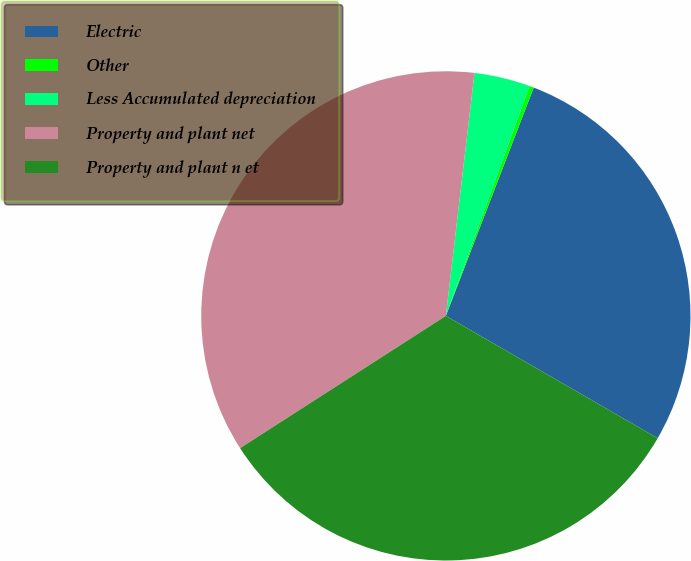Convert chart to OTSL. <chart><loc_0><loc_0><loc_500><loc_500><pie_chart><fcel>Electric<fcel>Other<fcel>Less Accumulated depreciation<fcel>Property and plant net<fcel>Property and plant n et<nl><fcel>27.49%<fcel>0.29%<fcel>3.69%<fcel>35.96%<fcel>32.57%<nl></chart> 